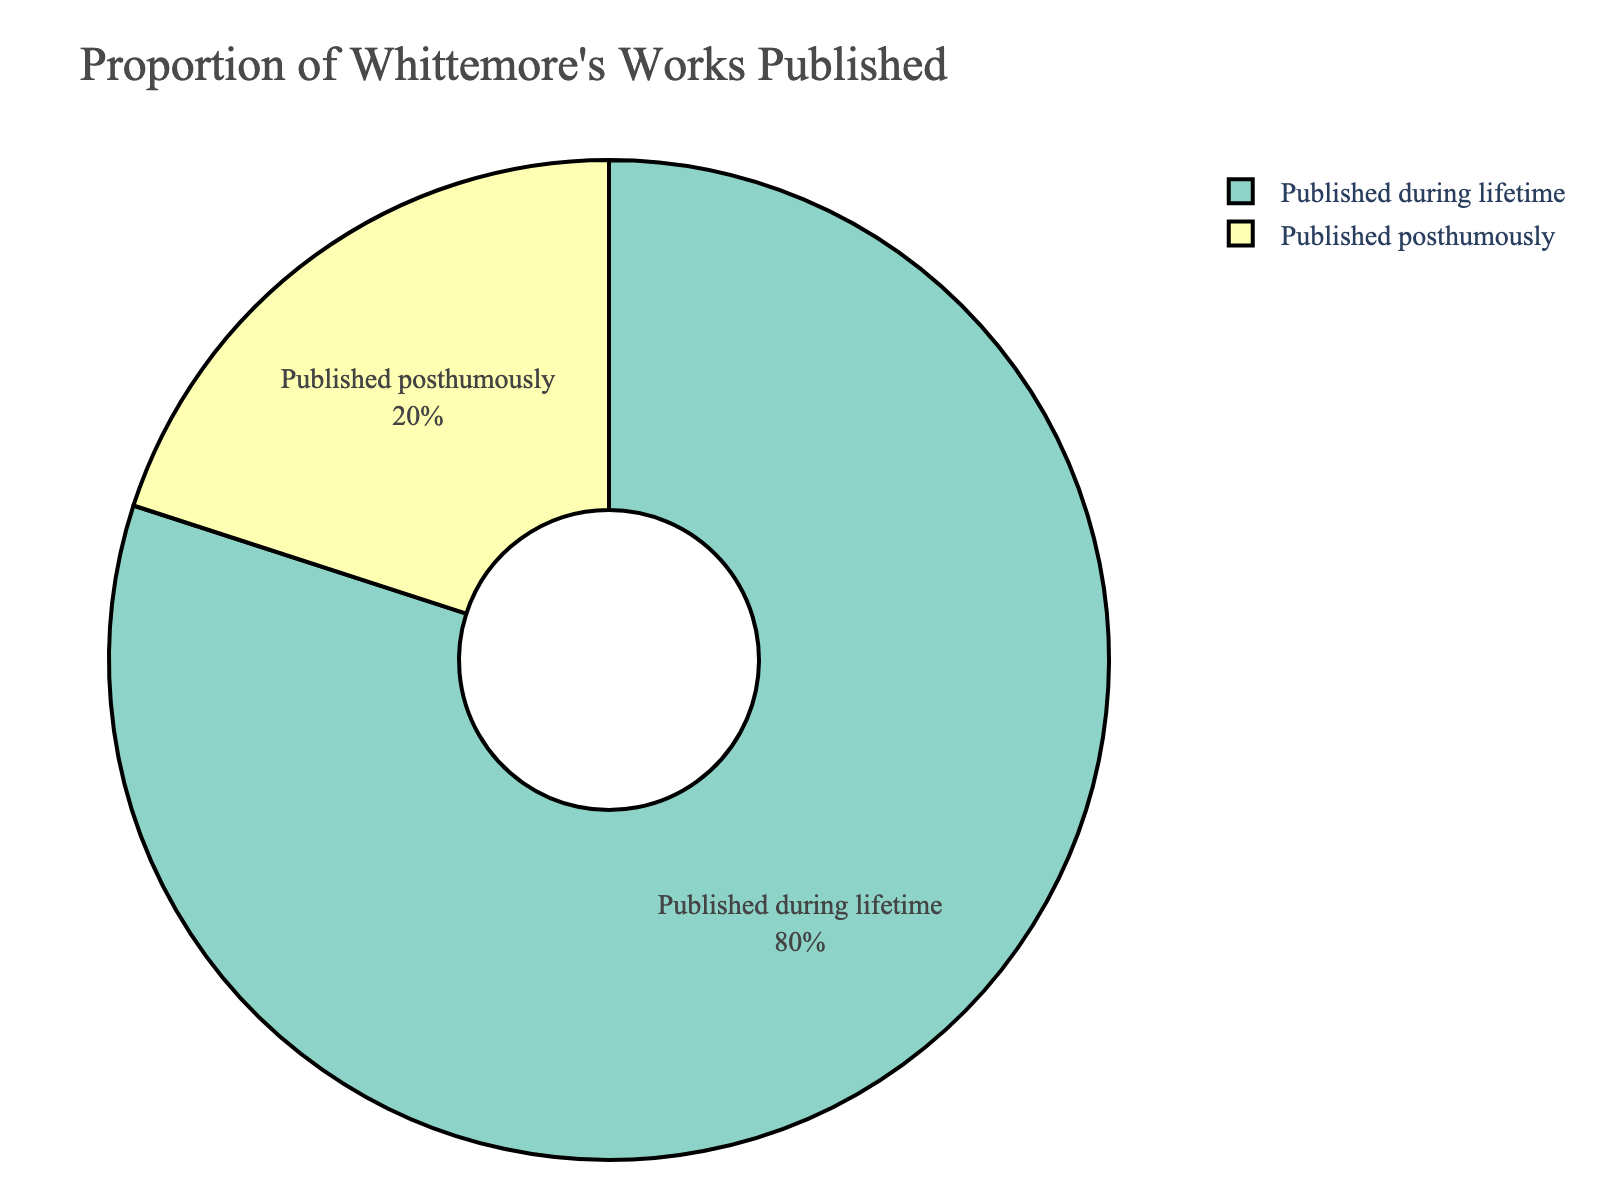What proportion of Whittemore's works were published during his lifetime? The pie chart shows two sections indicating the proportions. The section labeled "Published during lifetime" represents 80% of the total.
Answer: 80% What proportion of Whittemore's works were published posthumously? The pie chart shows two sections indicating the proportions. The section labeled "Published posthumously" represents 20% of the total.
Answer: 20% Which publication status has a higher proportion of works, published during his lifetime or posthumously? By comparing the sizes of the two sections in the pie chart, the section labeled "Published during lifetime" is larger than the one labeled "Published posthumously." Therefore, works published during his lifetime have a higher proportion.
Answer: Published during lifetime What is the ratio of works published during Whittemore's lifetime to those published posthumously? The proportion of works published during his lifetime is 0.80 and those published posthumously is 0.20. The ratio can be computed as 0.80 / 0.20.
Answer: 4:1 If Whittemore had 10 works in total, how many were published during his lifetime and how many were published posthumously? Given the proportions: 80% during his lifetime and 20% posthumously. Multiply these percentages by the total number of works (10). Therefore, 0.80 * 10 = 8 works during his lifetime, and 0.20 * 10 = 2 works posthumously.
Answer: 8 published during lifetime, 2 published posthumously Is the section representing works published during his lifetime larger than the section representing works published posthumously? Yes, visually, the section for works published during his lifetime is larger than the section for works published posthumously in the pie chart.
Answer: Yes If Whittemore had published 4 additional works posthumously, what would the new proportions be? Currently, 2 works are published posthumously, adding 4 more makes it 6. With a total of 14 works (8 during lifetime + 6 posthumously), the new proportions are: lifetime = 8/14 ≈ 0.5714 (57.14%), posthumously = 6/14 ≈ 0.4286 (42.86%).
Answer: 57.14% during lifetime, 42.86% posthumously What does the color coding in the chart represent? The color coding distinguishes between the two categories of publication status. Each section in the pie chart is colored differently; one color represents works published during Whittemore's lifetime while another color represents works published posthumously.
Answer: Publication status If the publication status distributions were equal, what would each proportion be? For equal distribution, the proportions for both publication statuses would be 50%. Each section of the pie chart would take up exactly half the circle.
Answer: 50% each What is the difference in proportion between works published during Whittemore's lifetime and posthumously? The proportion of works published during his lifetime is 80% and posthumously is 20%. The difference can be calculated as 80% - 20% = 60%.
Answer: 60% 